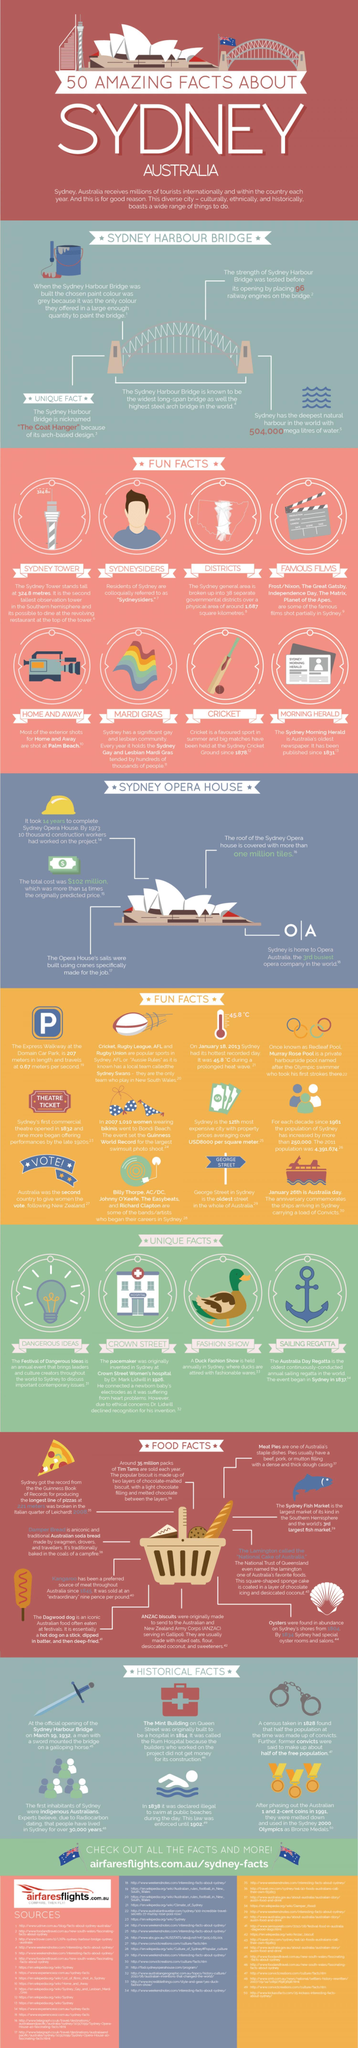what was used to test strength of the sydney harbour bridge
Answer the question with a short phrase. 96 railway engines What are residents of sydney also known as "sydneysiders" when was the largest swimsuit photo shoot 2007 Where is Mardi Gras held sydney What is the nickname of Sydney Harbour Bridge the coat hanger what is O | A Opera Australia what unique fact is the anchor showing sailing regatta 